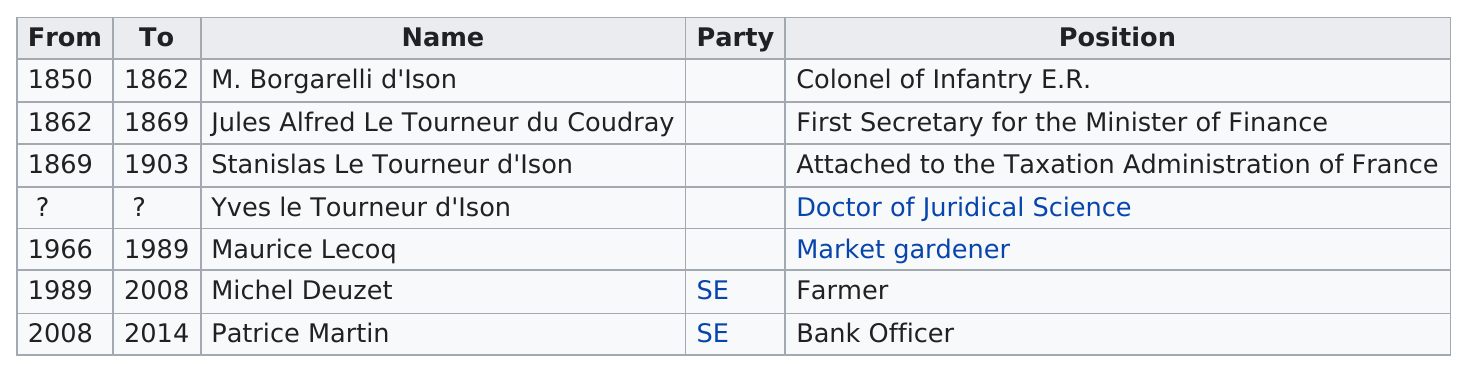Highlight a few significant elements in this photo. Three mayors of Aran had the surname D'Ison. During the period between 1970 and 2010, three different mayors served. Stanislas Le Tourneur d'Ison served in office for a total of 34 years. Maurice Le Coq was a market gardener for 23 years. Michel Deuzet, the mayor of Airaan, was affiliated with the SE Party and was a farmer. 